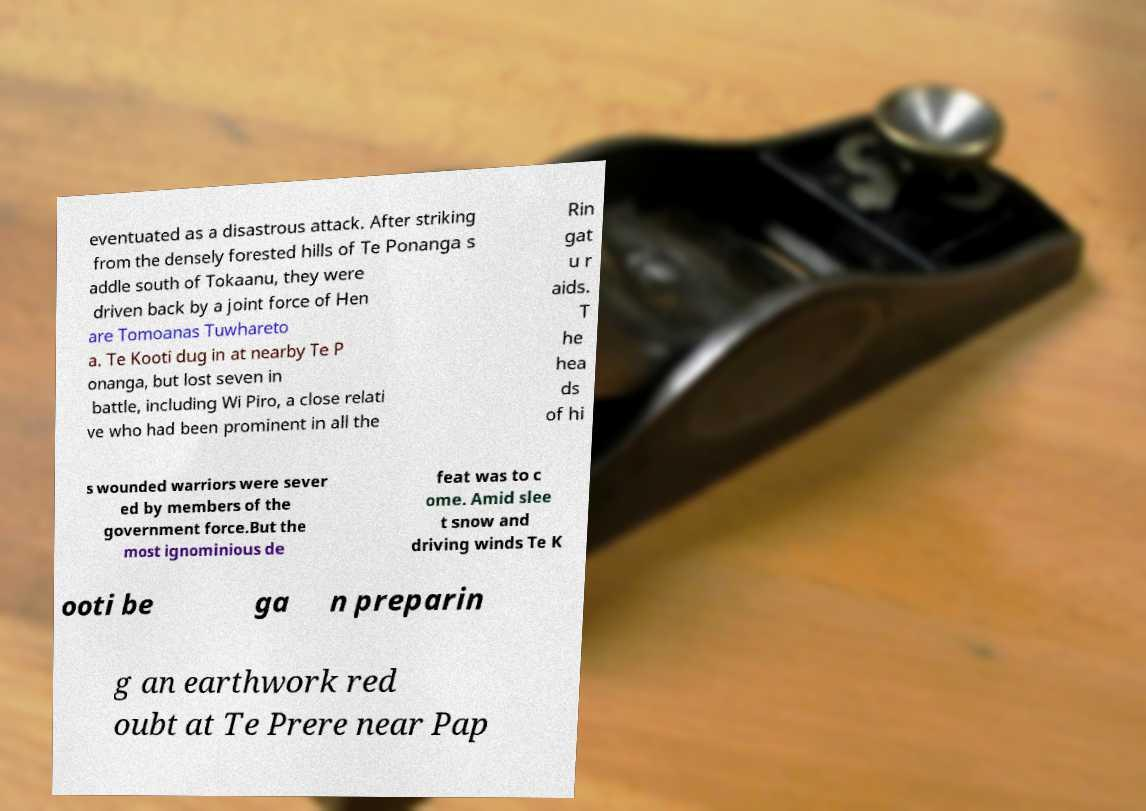Can you read and provide the text displayed in the image?This photo seems to have some interesting text. Can you extract and type it out for me? eventuated as a disastrous attack. After striking from the densely forested hills of Te Ponanga s addle south of Tokaanu, they were driven back by a joint force of Hen are Tomoanas Tuwhareto a. Te Kooti dug in at nearby Te P onanga, but lost seven in battle, including Wi Piro, a close relati ve who had been prominent in all the Rin gat u r aids. T he hea ds of hi s wounded warriors were sever ed by members of the government force.But the most ignominious de feat was to c ome. Amid slee t snow and driving winds Te K ooti be ga n preparin g an earthwork red oubt at Te Prere near Pap 